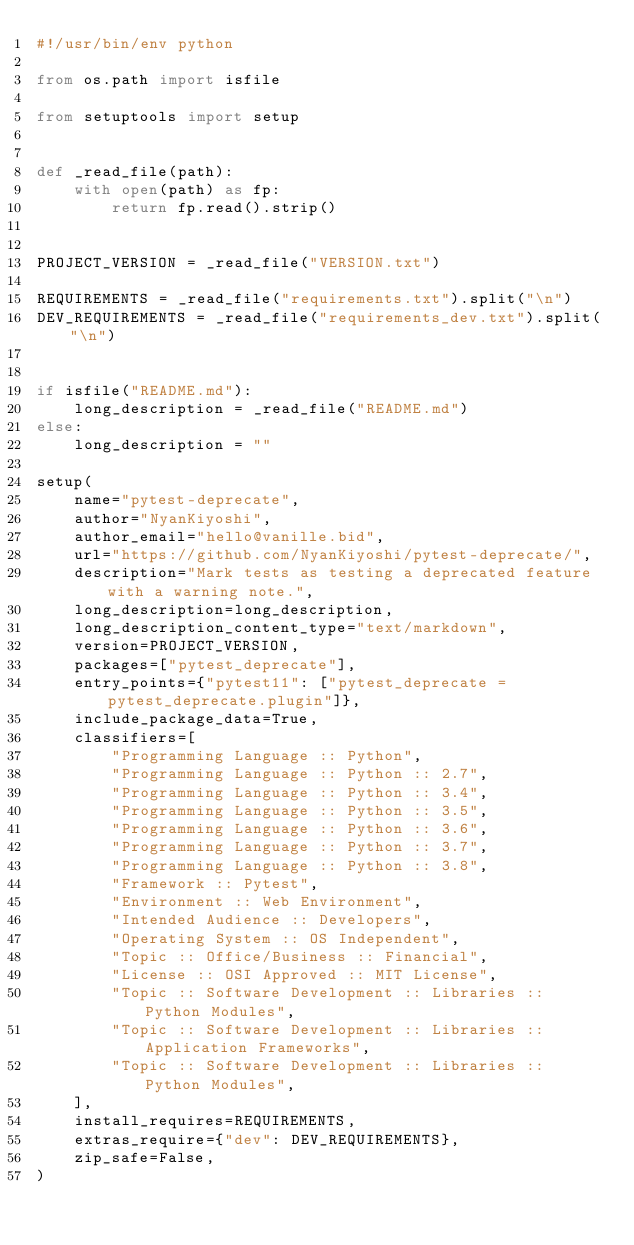<code> <loc_0><loc_0><loc_500><loc_500><_Python_>#!/usr/bin/env python

from os.path import isfile

from setuptools import setup


def _read_file(path):
    with open(path) as fp:
        return fp.read().strip()


PROJECT_VERSION = _read_file("VERSION.txt")

REQUIREMENTS = _read_file("requirements.txt").split("\n")
DEV_REQUIREMENTS = _read_file("requirements_dev.txt").split("\n")


if isfile("README.md"):
    long_description = _read_file("README.md")
else:
    long_description = ""

setup(
    name="pytest-deprecate",
    author="NyanKiyoshi",
    author_email="hello@vanille.bid",
    url="https://github.com/NyanKiyoshi/pytest-deprecate/",
    description="Mark tests as testing a deprecated feature with a warning note.",
    long_description=long_description,
    long_description_content_type="text/markdown",
    version=PROJECT_VERSION,
    packages=["pytest_deprecate"],
    entry_points={"pytest11": ["pytest_deprecate = pytest_deprecate.plugin"]},
    include_package_data=True,
    classifiers=[
        "Programming Language :: Python",
        "Programming Language :: Python :: 2.7",
        "Programming Language :: Python :: 3.4",
        "Programming Language :: Python :: 3.5",
        "Programming Language :: Python :: 3.6",
        "Programming Language :: Python :: 3.7",
        "Programming Language :: Python :: 3.8",
        "Framework :: Pytest",
        "Environment :: Web Environment",
        "Intended Audience :: Developers",
        "Operating System :: OS Independent",
        "Topic :: Office/Business :: Financial",
        "License :: OSI Approved :: MIT License",
        "Topic :: Software Development :: Libraries :: Python Modules",
        "Topic :: Software Development :: Libraries :: Application Frameworks",
        "Topic :: Software Development :: Libraries :: Python Modules",
    ],
    install_requires=REQUIREMENTS,
    extras_require={"dev": DEV_REQUIREMENTS},
    zip_safe=False,
)
</code> 